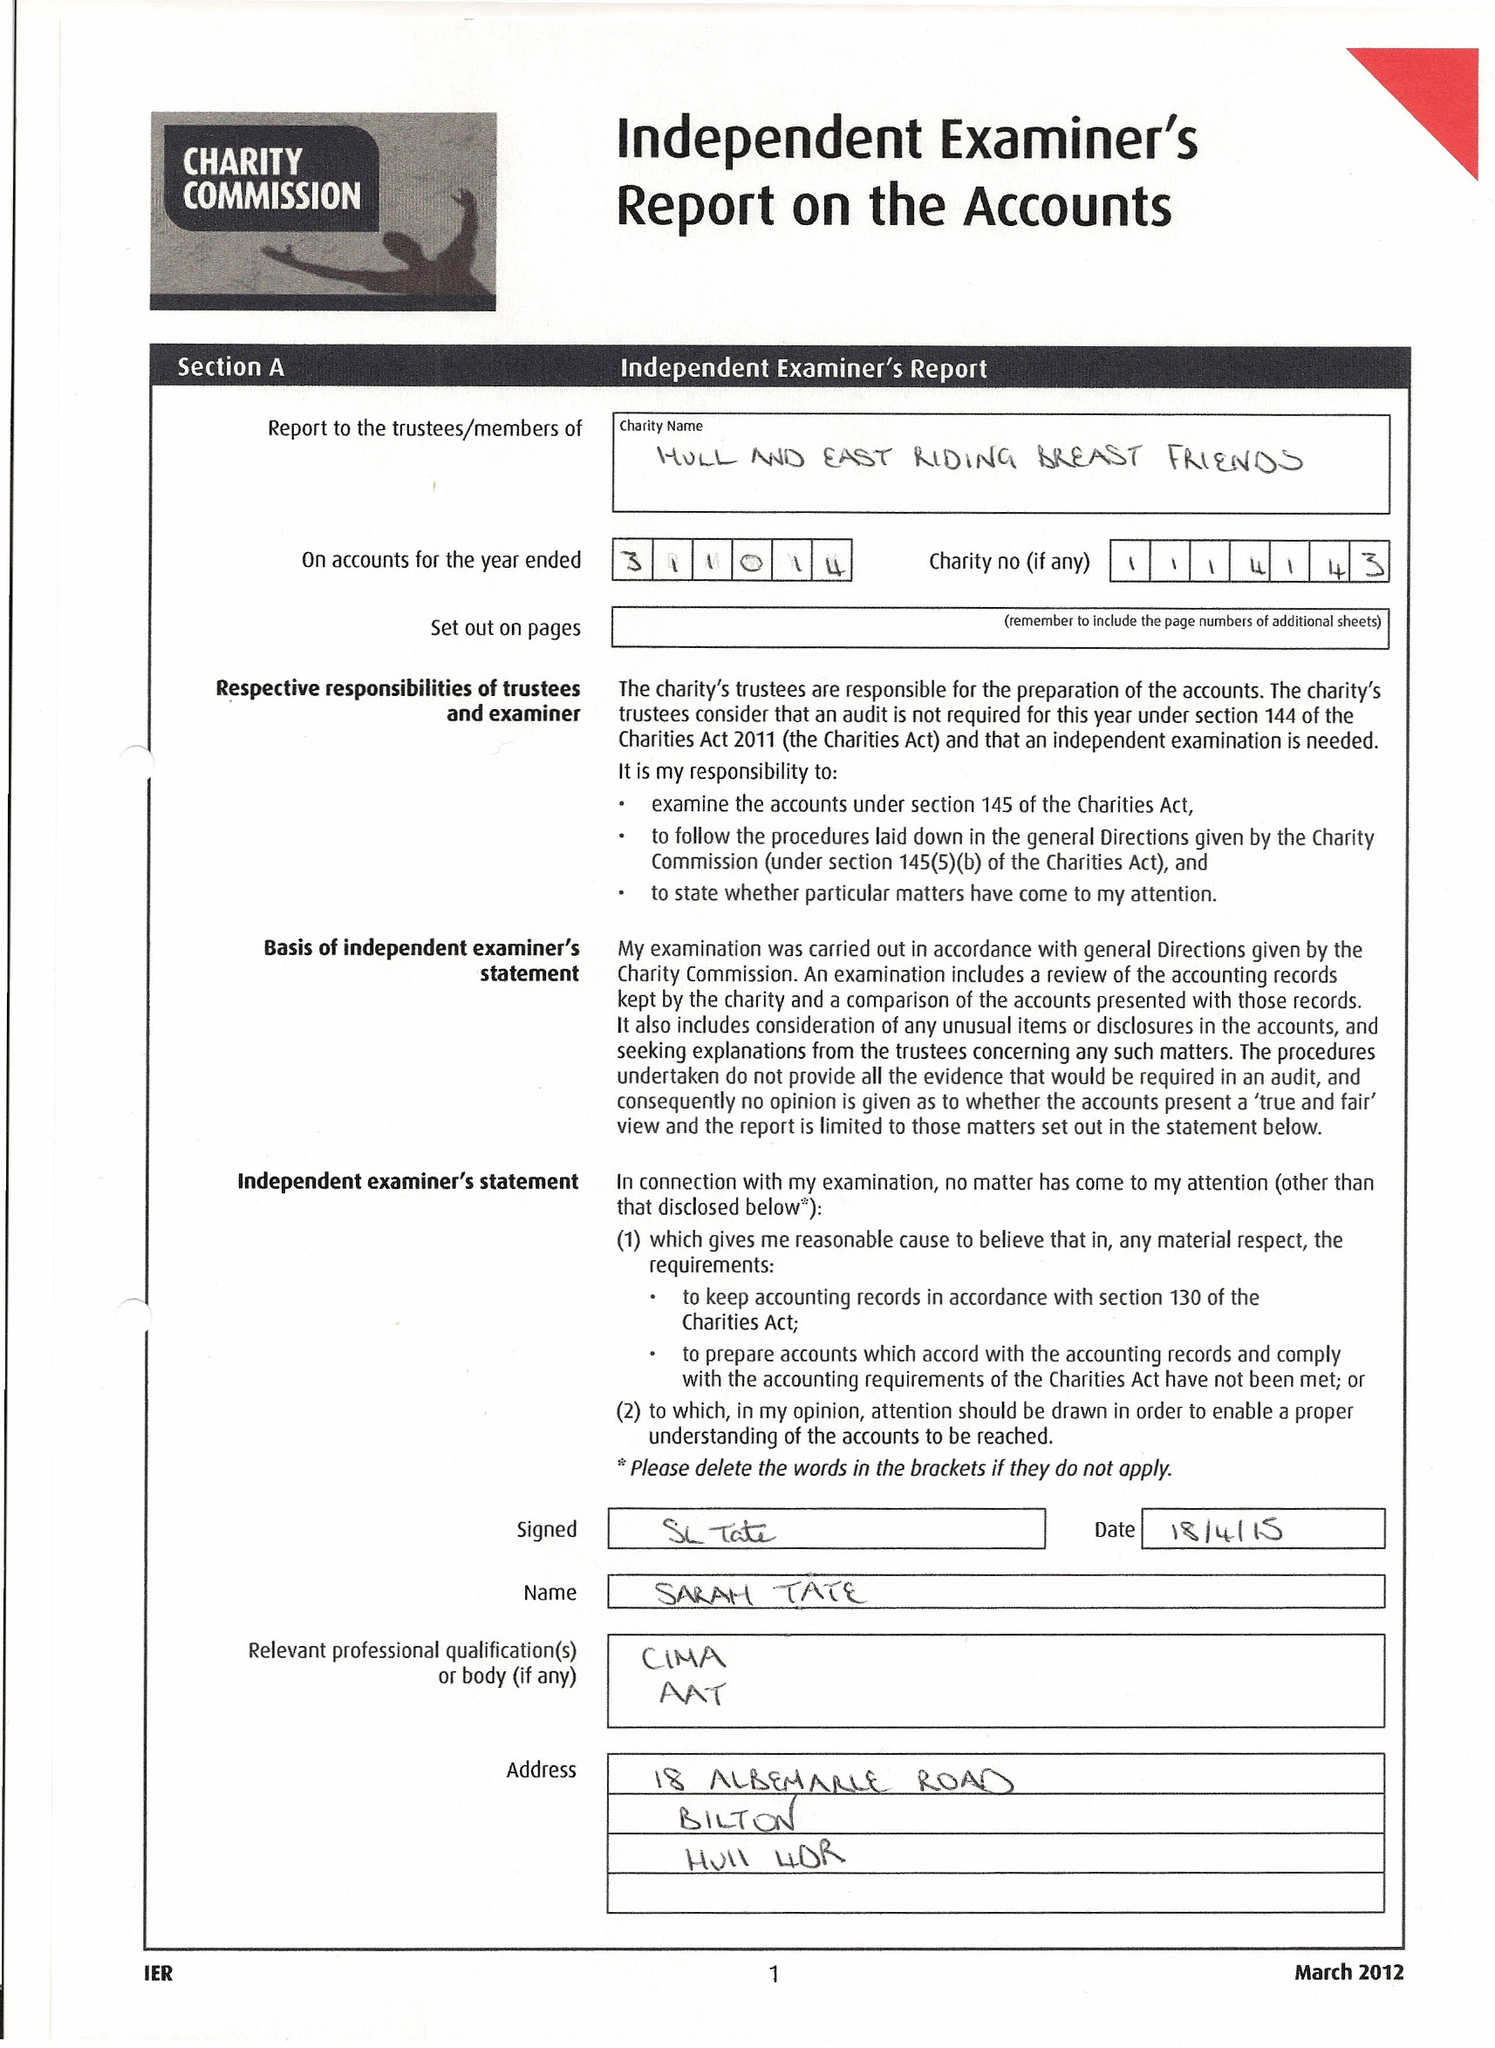What is the value for the charity_name?
Answer the question using a single word or phrase. Hull and East Riding Breast Friends 